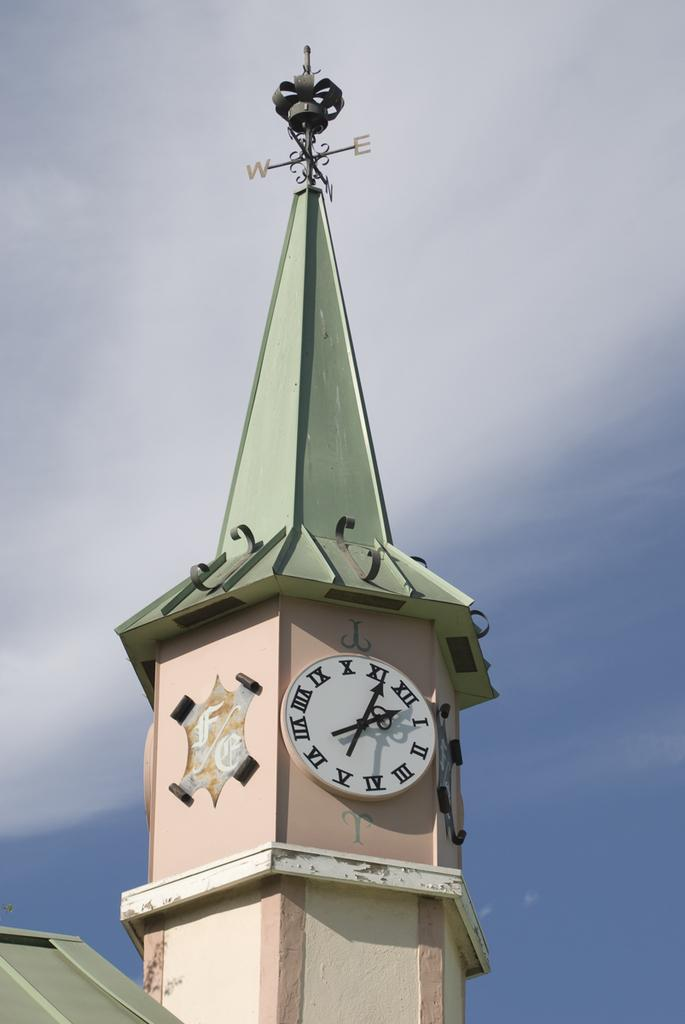Provide a one-sentence caption for the provided image. A clock tower showing the time 2:05 has a weather vane on top. 